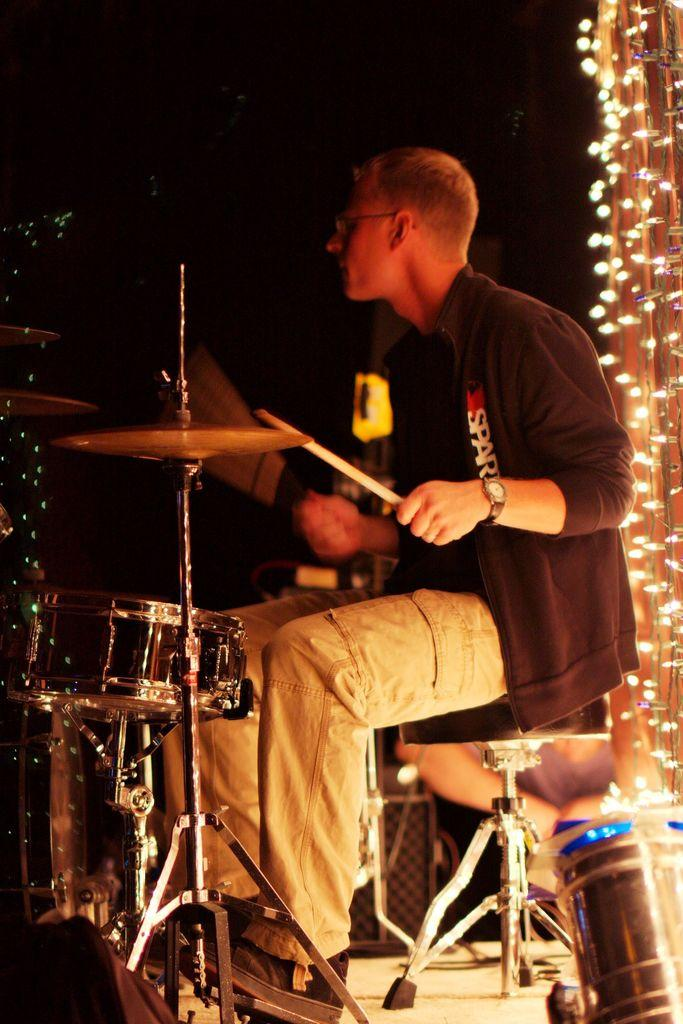How many people are in the group in the image? The number of people in the group is not specified in the facts, so it cannot be determined from the information provided. What are the people doing in the image? The people in the image are standing in front of a building, holding hands, and smiling. What is the background of the image? The background of the image is a building. What is the emotional state of the people in the image? The people in the image are smiling, which suggests a positive emotional state. What type of sand can be seen on the ground in the image? There is no sand present in the image; it features a group of people standing in front of a building. How does the distribution of the flight affect the image? There is no flight present in the image, so its distribution cannot affect the image. 